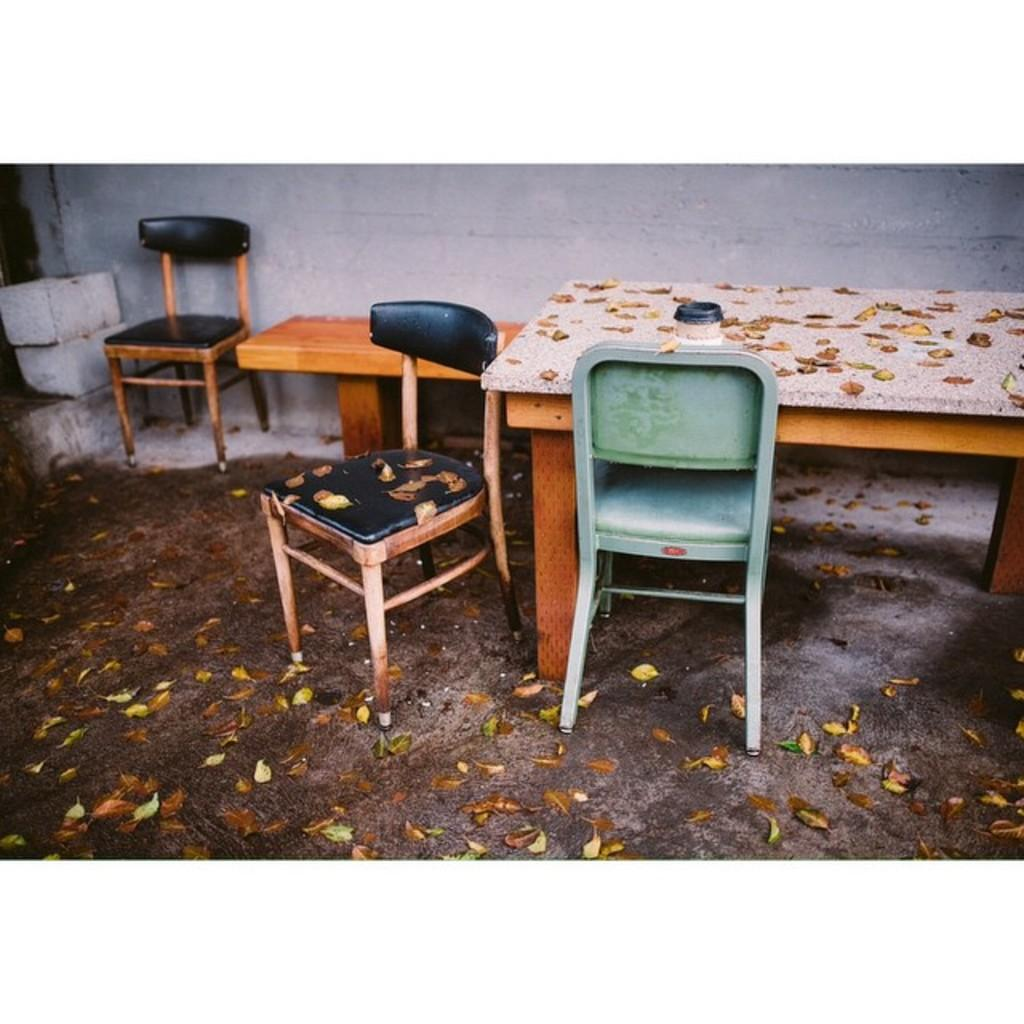What type of furniture is present in the image? There are chairs and a table in the image. Is there any seating other than chairs in the image? Yes, there is a bench in the image. What is on the ground in the image? Bricks and leaves are present on the ground in the image. What can be seen in the background of the image? There is a wall visible in the background of the image. What type of development is taking place in the image? There is no development project or construction visible in the image; it primarily features furniture and ground elements. 